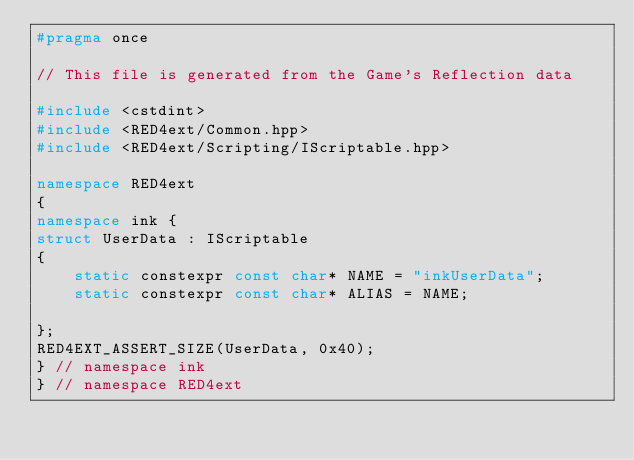<code> <loc_0><loc_0><loc_500><loc_500><_C++_>#pragma once

// This file is generated from the Game's Reflection data

#include <cstdint>
#include <RED4ext/Common.hpp>
#include <RED4ext/Scripting/IScriptable.hpp>

namespace RED4ext
{
namespace ink { 
struct UserData : IScriptable
{
    static constexpr const char* NAME = "inkUserData";
    static constexpr const char* ALIAS = NAME;

};
RED4EXT_ASSERT_SIZE(UserData, 0x40);
} // namespace ink
} // namespace RED4ext
</code> 